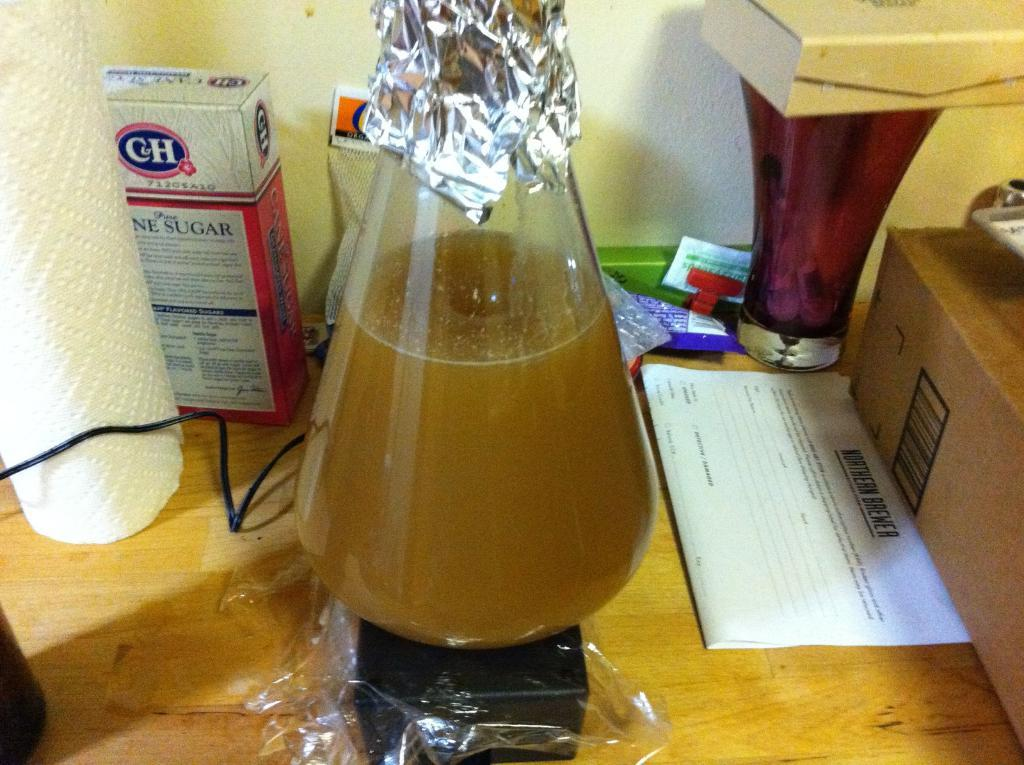<image>
Give a short and clear explanation of the subsequent image. A box of "C&H" cane sugar sits behind a flask. 